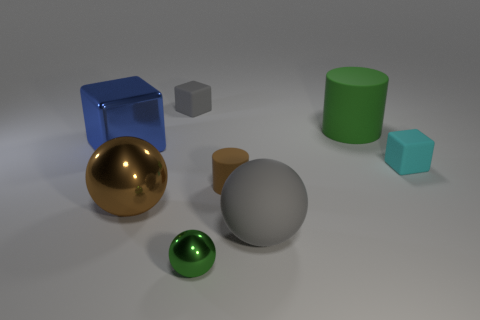Is there another cylinder made of the same material as the small cylinder?
Make the answer very short. Yes. Does the matte cylinder left of the large green thing have the same color as the big cylinder?
Ensure brevity in your answer.  No. The brown metal ball is what size?
Offer a very short reply. Large. Are there any gray blocks that are left of the rubber cylinder that is in front of the big green rubber cylinder behind the small green shiny sphere?
Provide a succinct answer. Yes. There is a green shiny ball; what number of tiny green metallic balls are in front of it?
Your answer should be very brief. 0. What number of things are the same color as the tiny matte cylinder?
Provide a short and direct response. 1. How many things are either tiny things behind the small metal sphere or rubber objects in front of the large brown ball?
Offer a very short reply. 4. Are there more big shiny spheres than metallic spheres?
Ensure brevity in your answer.  No. What is the color of the large sphere behind the big gray rubber sphere?
Ensure brevity in your answer.  Brown. Is the small cyan thing the same shape as the large blue object?
Provide a succinct answer. Yes. 